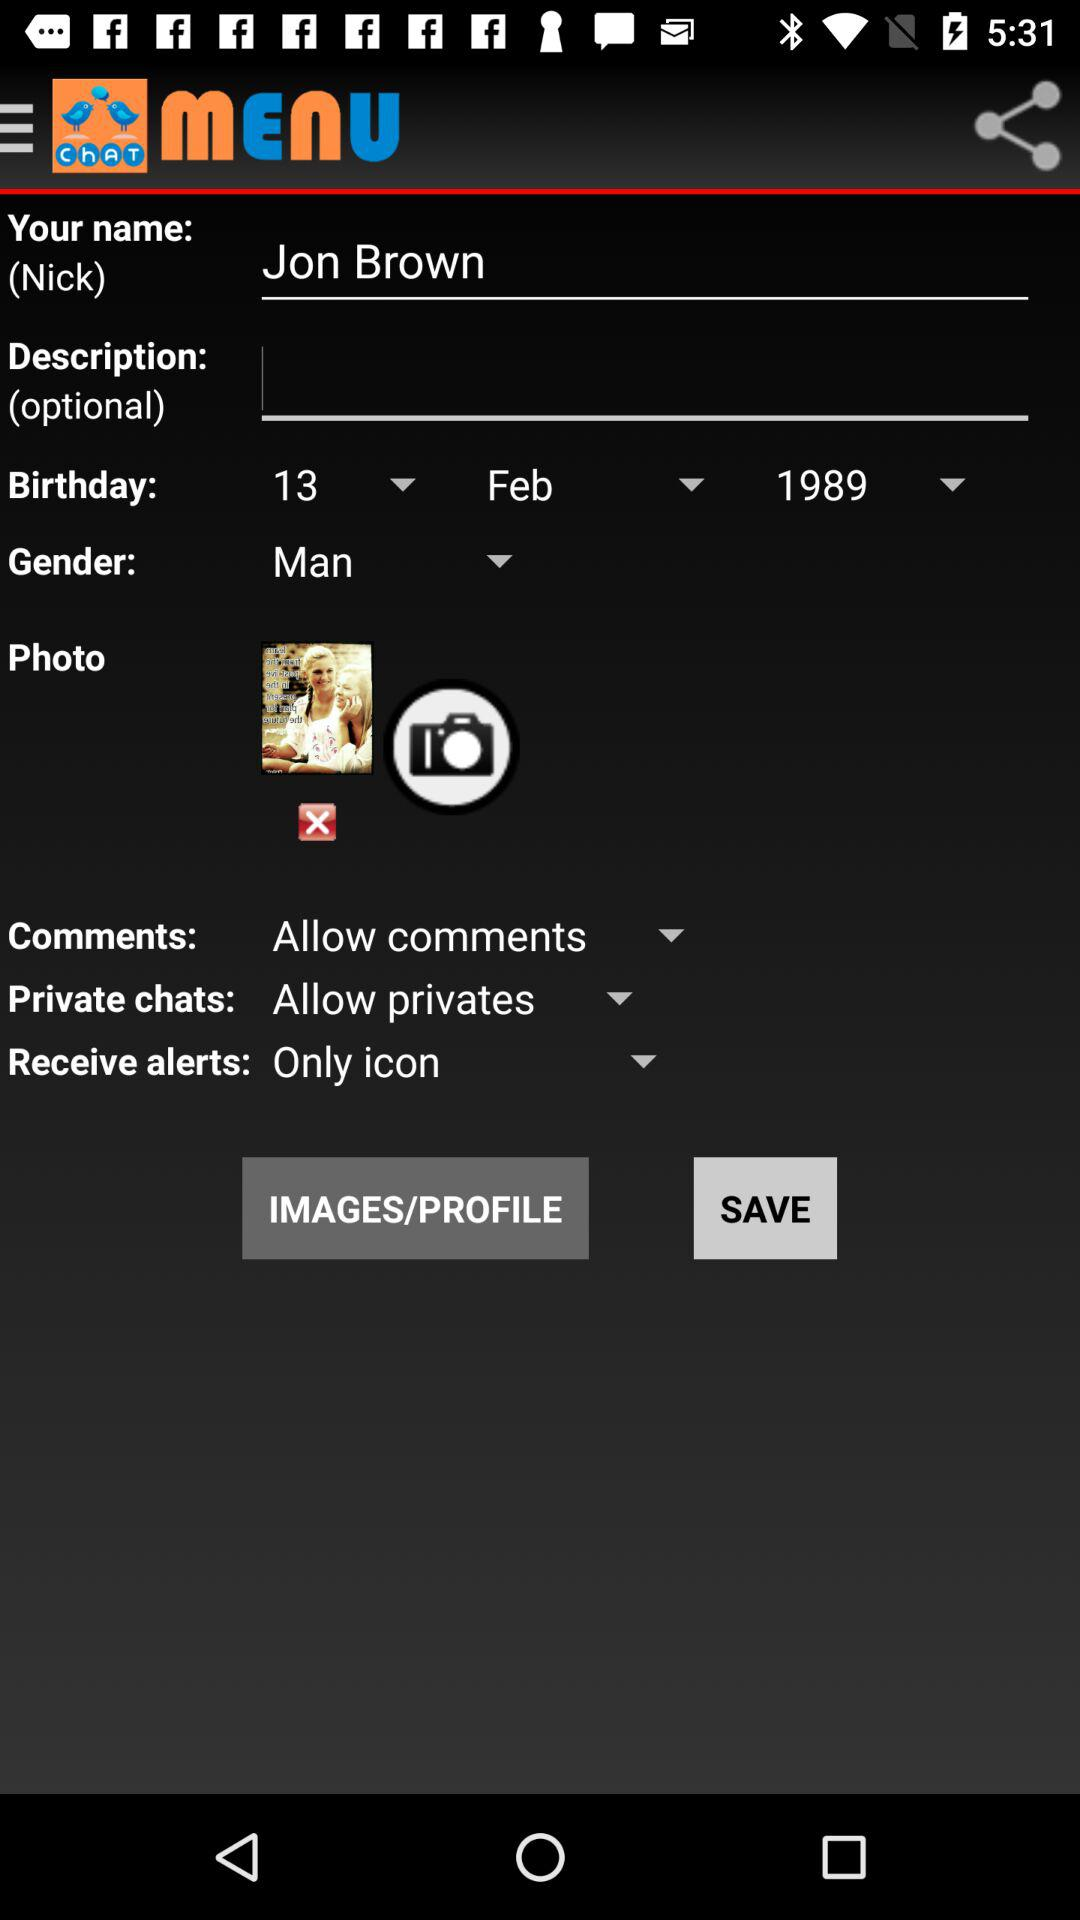What option is selected for comments? The option selected for comments is "Allow comments". 